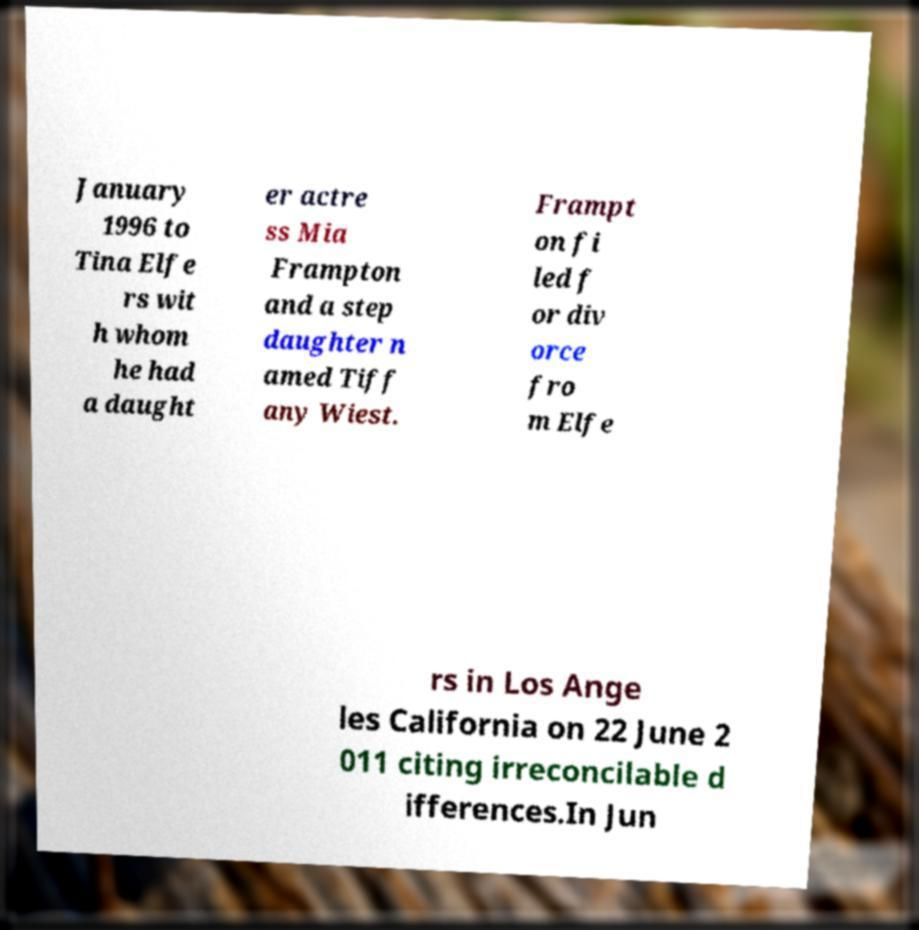Can you read and provide the text displayed in the image?This photo seems to have some interesting text. Can you extract and type it out for me? January 1996 to Tina Elfe rs wit h whom he had a daught er actre ss Mia Frampton and a step daughter n amed Tiff any Wiest. Frampt on fi led f or div orce fro m Elfe rs in Los Ange les California on 22 June 2 011 citing irreconcilable d ifferences.In Jun 